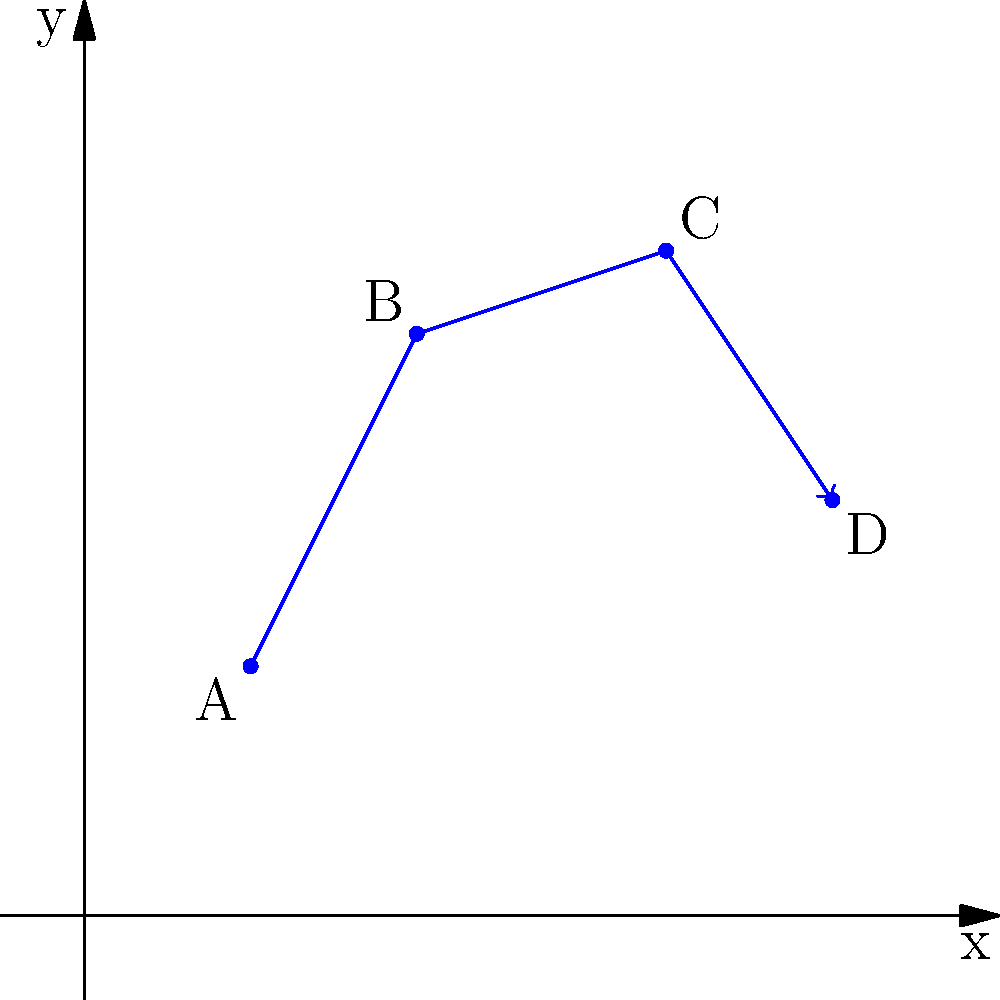A wildlife tracking study has recorded the migration pattern of a rare bird species using a 2D coordinate system, where each unit represents 10 km. The birds were observed at four locations: A(2,3), B(4,7), C(7,8), and D(9,5). What is the total distance traveled by the birds along this migration route, rounded to the nearest kilometer? To solve this problem, we need to calculate the distances between consecutive points and sum them up. Let's break it down step-by-step:

1. Calculate the distance from A to B:
   $d_{AB} = \sqrt{(x_B - x_A)^2 + (y_B - y_A)^2} = \sqrt{(4-2)^2 + (7-3)^2} = \sqrt{4^2 + 4^2} = \sqrt{32} \approx 5.66$ units

2. Calculate the distance from B to C:
   $d_{BC} = \sqrt{(x_C - x_B)^2 + (y_C - y_B)^2} = \sqrt{(7-4)^2 + (8-7)^2} = \sqrt{3^2 + 1^2} = \sqrt{10} \approx 3.16$ units

3. Calculate the distance from C to D:
   $d_{CD} = \sqrt{(x_D - x_C)^2 + (y_D - y_C)^2} = \sqrt{(9-7)^2 + (5-8)^2} = \sqrt{2^2 + (-3)^2} = \sqrt{13} \approx 3.61$ units

4. Sum up all distances:
   Total distance = $d_{AB} + d_{BC} + d_{CD} \approx 5.66 + 3.16 + 3.61 = 12.43$ units

5. Convert units to kilometers:
   12.43 units × 10 km/unit = 124.3 km

6. Round to the nearest kilometer:
   124.3 km ≈ 124 km

Therefore, the total distance traveled by the birds along this migration route is approximately 124 km.
Answer: 124 km 